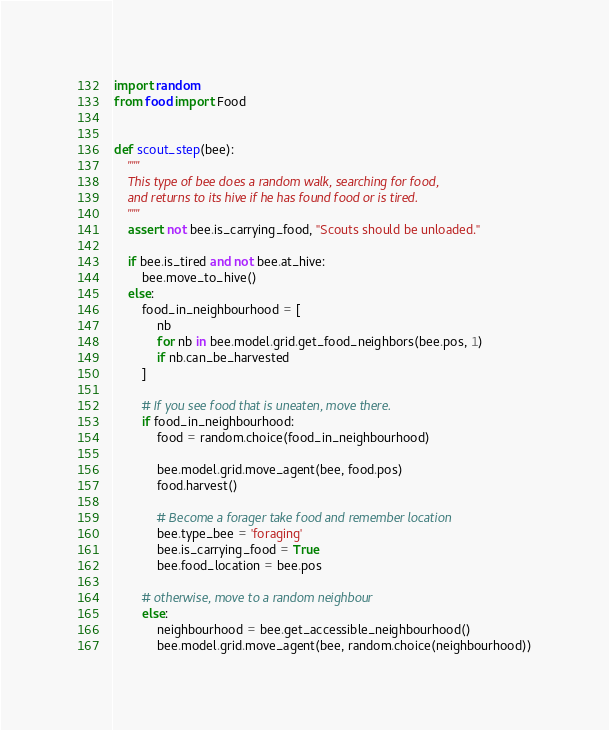Convert code to text. <code><loc_0><loc_0><loc_500><loc_500><_Python_>import random
from food import Food


def scout_step(bee):
    """
    This type of bee does a random walk, searching for food,
    and returns to its hive if he has found food or is tired.
    """
    assert not bee.is_carrying_food, "Scouts should be unloaded."

    if bee.is_tired and not bee.at_hive:
        bee.move_to_hive()
    else:
        food_in_neighbourhood = [
            nb
            for nb in bee.model.grid.get_food_neighbors(bee.pos, 1)
            if nb.can_be_harvested
        ]

        # If you see food that is uneaten, move there.
        if food_in_neighbourhood:
            food = random.choice(food_in_neighbourhood)

            bee.model.grid.move_agent(bee, food.pos)
            food.harvest()

            # Become a forager take food and remember location
            bee.type_bee = 'foraging'
            bee.is_carrying_food = True
            bee.food_location = bee.pos

        # otherwise, move to a random neighbour
        else:
            neighbourhood = bee.get_accessible_neighbourhood()
            bee.model.grid.move_agent(bee, random.choice(neighbourhood))

</code> 